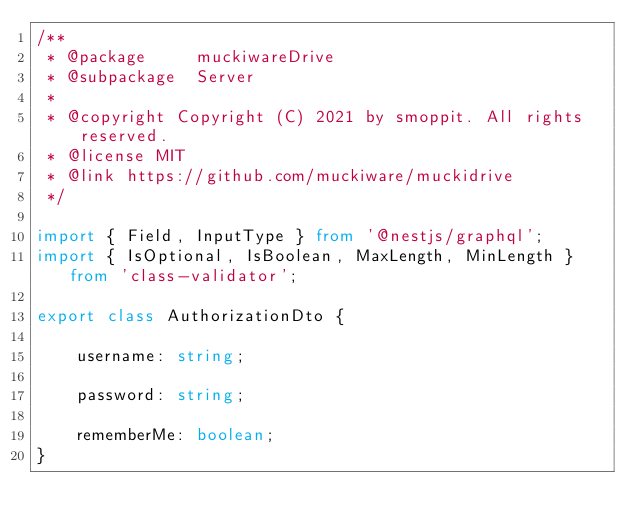Convert code to text. <code><loc_0><loc_0><loc_500><loc_500><_TypeScript_>/**
 * @package     muckiwareDrive
 * @subpackage  Server
 *
 * @copyright Copyright (C) 2021 by smoppit. All rights reserved.
 * @license MIT
 * @link https://github.com/muckiware/muckidrive
 */

import { Field, InputType } from '@nestjs/graphql';
import { IsOptional, IsBoolean, MaxLength, MinLength } from 'class-validator';

export class AuthorizationDto {

    username: string;

    password: string;

    rememberMe: boolean;
}
</code> 